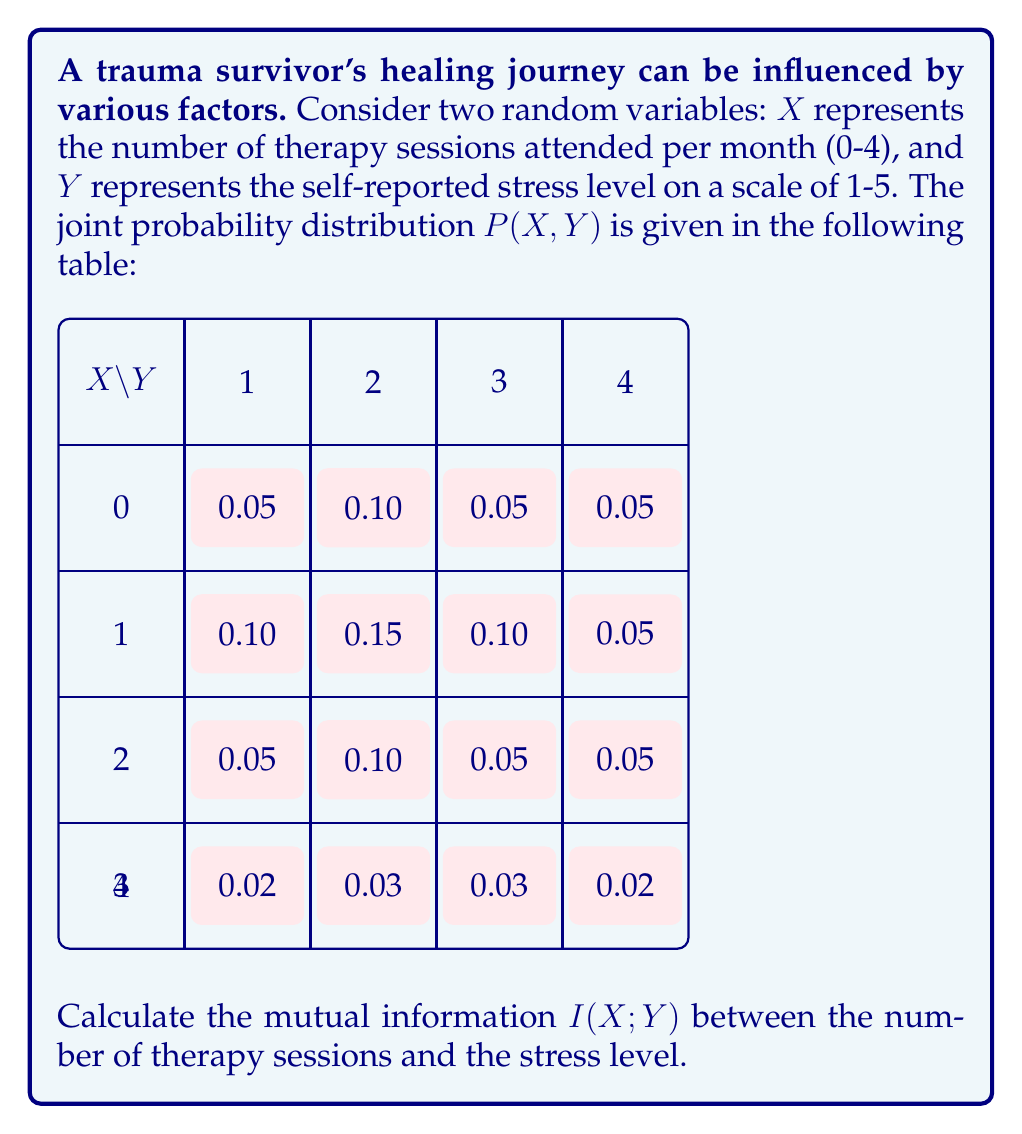Give your solution to this math problem. To calculate the mutual information I(X;Y), we'll follow these steps:

1) First, we need to calculate the marginal probabilities P(X) and P(Y):

   P(X=0) = 0.05 + 0.10 + 0.05 + 0.05 = 0.25
   P(X=1) = 0.10 + 0.15 + 0.10 + 0.05 = 0.40
   P(X=2) = 0.05 + 0.10 + 0.05 + 0.05 = 0.25
   P(X=3) = 0.02 + 0.03 + 0.03 + 0.02 = 0.10

   P(Y=1) = 0.05 + 0.10 + 0.05 + 0.02 = 0.22
   P(Y=2) = 0.10 + 0.15 + 0.10 + 0.03 = 0.38
   P(Y=3) = 0.05 + 0.10 + 0.05 + 0.03 = 0.23
   P(Y=4) = 0.05 + 0.05 + 0.05 + 0.02 = 0.17

2) The formula for mutual information is:

   $$I(X;Y) = \sum_{x}\sum_{y} P(x,y) \log_2 \frac{P(x,y)}{P(x)P(y)}$$

3) Let's calculate each term:

   For X=0, Y=1: 0.05 * log2(0.05 / (0.25 * 0.22)) = -0.0280
   For X=0, Y=2: 0.10 * log2(0.10 / (0.25 * 0.38)) = 0.0120
   For X=0, Y=3: 0.05 * log2(0.05 / (0.25 * 0.23)) = -0.0165
   For X=0, Y=4: 0.05 * log2(0.05 / (0.25 * 0.17)) = 0.0067

   For X=1, Y=1: 0.10 * log2(0.10 / (0.40 * 0.22)) = 0.0305
   For X=1, Y=2: 0.15 * log2(0.15 / (0.40 * 0.38)) = 0.0165
   For X=1, Y=3: 0.10 * log2(0.10 / (0.40 * 0.23)) = 0.0149
   For X=1, Y=4: 0.05 * log2(0.05 / (0.40 * 0.17)) = -0.0193

   For X=2, Y=1: 0.05 * log2(0.05 / (0.25 * 0.22)) = -0.0165
   For X=2, Y=2: 0.10 * log2(0.10 / (0.25 * 0.38)) = 0.0120
   For X=2, Y=3: 0.05 * log2(0.05 / (0.25 * 0.23)) = -0.0165
   For X=2, Y=4: 0.05 * log2(0.05 / (0.25 * 0.17)) = 0.0067

   For X=3, Y=1: 0.02 * log2(0.02 / (0.10 * 0.22)) = -0.0042
   For X=3, Y=2: 0.03 * log2(0.03 / (0.10 * 0.38)) = -0.0047
   For X=3, Y=3: 0.03 * log2(0.03 / (0.10 * 0.23)) = 0.0015
   For X=3, Y=4: 0.02 * log2(0.02 / (0.10 * 0.17)) = 0.0017

4) Sum all these terms:

   I(X;Y) = -0.0280 + 0.0120 - 0.0165 + 0.0067 + 0.0305 + 0.0165 + 0.0149 - 0.0193 - 0.0165 + 0.0120 - 0.0165 + 0.0067 - 0.0042 - 0.0047 + 0.0015 + 0.0017 = 0.0168

Therefore, the mutual information I(X;Y) is approximately 0.0168 bits.
Answer: 0.0168 bits 